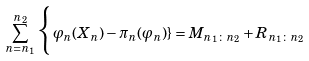<formula> <loc_0><loc_0><loc_500><loc_500>\sum _ { n = n _ { 1 } } ^ { n _ { 2 } } \Big \{ \, \varphi _ { n } ( X _ { n } ) - \pi _ { n } ( \varphi _ { n } ) \} = M _ { n _ { 1 } \colon n _ { 2 } } + R _ { n _ { 1 } \colon n _ { 2 } }</formula> 